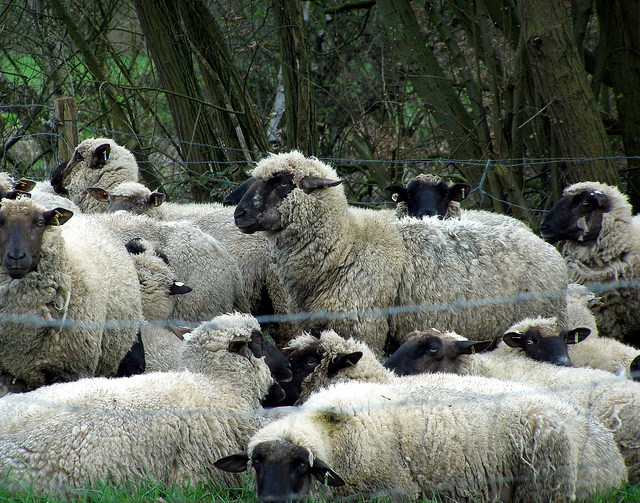What's the overall mood or atmosphere of this scene? The overall mood of the scene is peaceful and calm. The sheep appear relaxed and undisturbed in their environment, surrounded by the natural beauty of the trees and vegetation. There's a sense of contentment and tranquility among the flock. Suppose the sheep could talk, what might they be discussing? If the sheep could talk, they might be discussing their grazing experiences or reminiscing about past adventures. Perhaps they’d share thoughts on the best patches of grass, strategies for avoiding rain, or tales of the occasional visits from the shepherd. They could also be talking about any recent changes in their environment, like new scents or sounds they’ve noticed. Imagine a drone flew over this scene; what would it capture? A drone flying over this scene would capture a beautiful, sweeping view of the pastoral setting. It would show the dense green vegetation, the serene flock of sheep, and the natural landscape extending beyond the immediate vicinity. The footage would highlight the harmony and simplicity of rural life, with the sheep clustered near the fence and the surrounding trees offering a picturesque backdrop. 